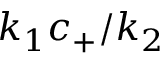Convert formula to latex. <formula><loc_0><loc_0><loc_500><loc_500>k _ { 1 } c _ { + } / k _ { 2 }</formula> 